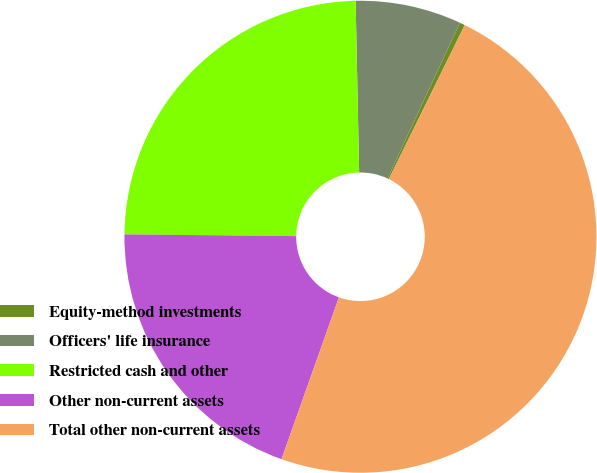Convert chart. <chart><loc_0><loc_0><loc_500><loc_500><pie_chart><fcel>Equity-method investments<fcel>Officers' life insurance<fcel>Restricted cash and other<fcel>Other non-current assets<fcel>Total other non-current assets<nl><fcel>0.36%<fcel>7.25%<fcel>24.51%<fcel>19.73%<fcel>48.14%<nl></chart> 